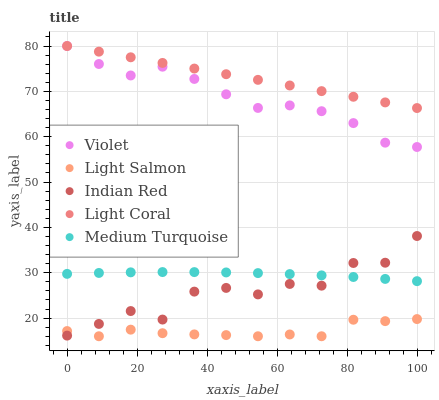Does Light Salmon have the minimum area under the curve?
Answer yes or no. Yes. Does Light Coral have the maximum area under the curve?
Answer yes or no. Yes. Does Medium Turquoise have the minimum area under the curve?
Answer yes or no. No. Does Medium Turquoise have the maximum area under the curve?
Answer yes or no. No. Is Light Coral the smoothest?
Answer yes or no. Yes. Is Indian Red the roughest?
Answer yes or no. Yes. Is Light Salmon the smoothest?
Answer yes or no. No. Is Light Salmon the roughest?
Answer yes or no. No. Does Light Salmon have the lowest value?
Answer yes or no. Yes. Does Medium Turquoise have the lowest value?
Answer yes or no. No. Does Violet have the highest value?
Answer yes or no. Yes. Does Medium Turquoise have the highest value?
Answer yes or no. No. Is Indian Red less than Violet?
Answer yes or no. Yes. Is Light Coral greater than Light Salmon?
Answer yes or no. Yes. Does Indian Red intersect Light Salmon?
Answer yes or no. Yes. Is Indian Red less than Light Salmon?
Answer yes or no. No. Is Indian Red greater than Light Salmon?
Answer yes or no. No. Does Indian Red intersect Violet?
Answer yes or no. No. 